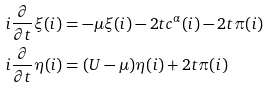Convert formula to latex. <formula><loc_0><loc_0><loc_500><loc_500>& i \frac { \partial } { \partial t } \xi ( i ) = - \mu \xi ( i ) - 2 t c ^ { \alpha } ( i ) - 2 t \pi ( i ) \\ & i \frac { \partial } { \partial t } \eta ( i ) = ( U - \mu ) \eta ( i ) + 2 t \pi ( i )</formula> 